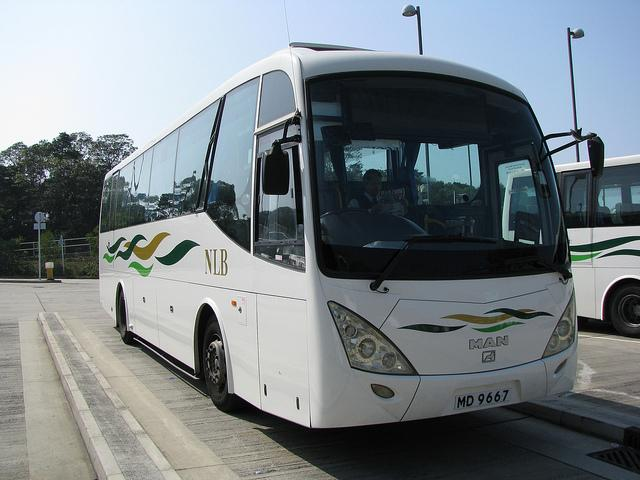What country does this bus originate from? Please explain your reasoning. hong kong. The nlb on the bus indicates this country 